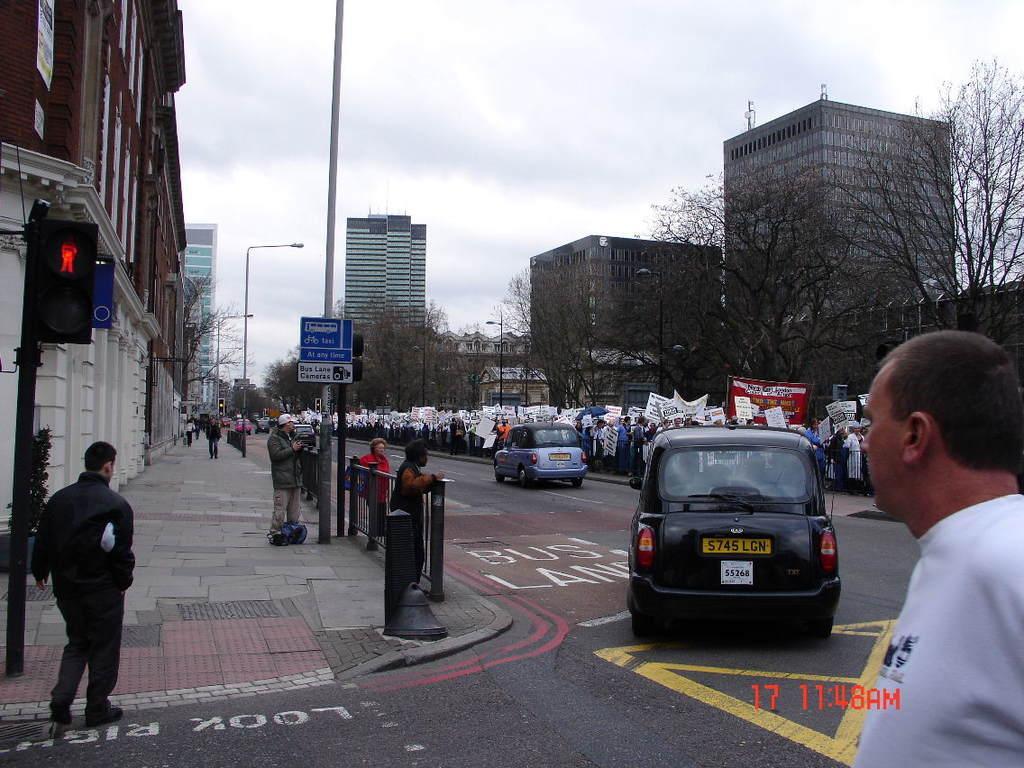Describe this image in one or two sentences. This is an outside view. On the right side there is a road and I can see few cars on the road. Beside the road a crowd of people holding banners and boards in the hands and standing. In the bottom right there is a man wearing white color t-shirt. On the left side there are few people walking on the footpath and few people are standing. On both sides of the road there are some trees, poles and buildings. At the top of the image I can see the sky. 